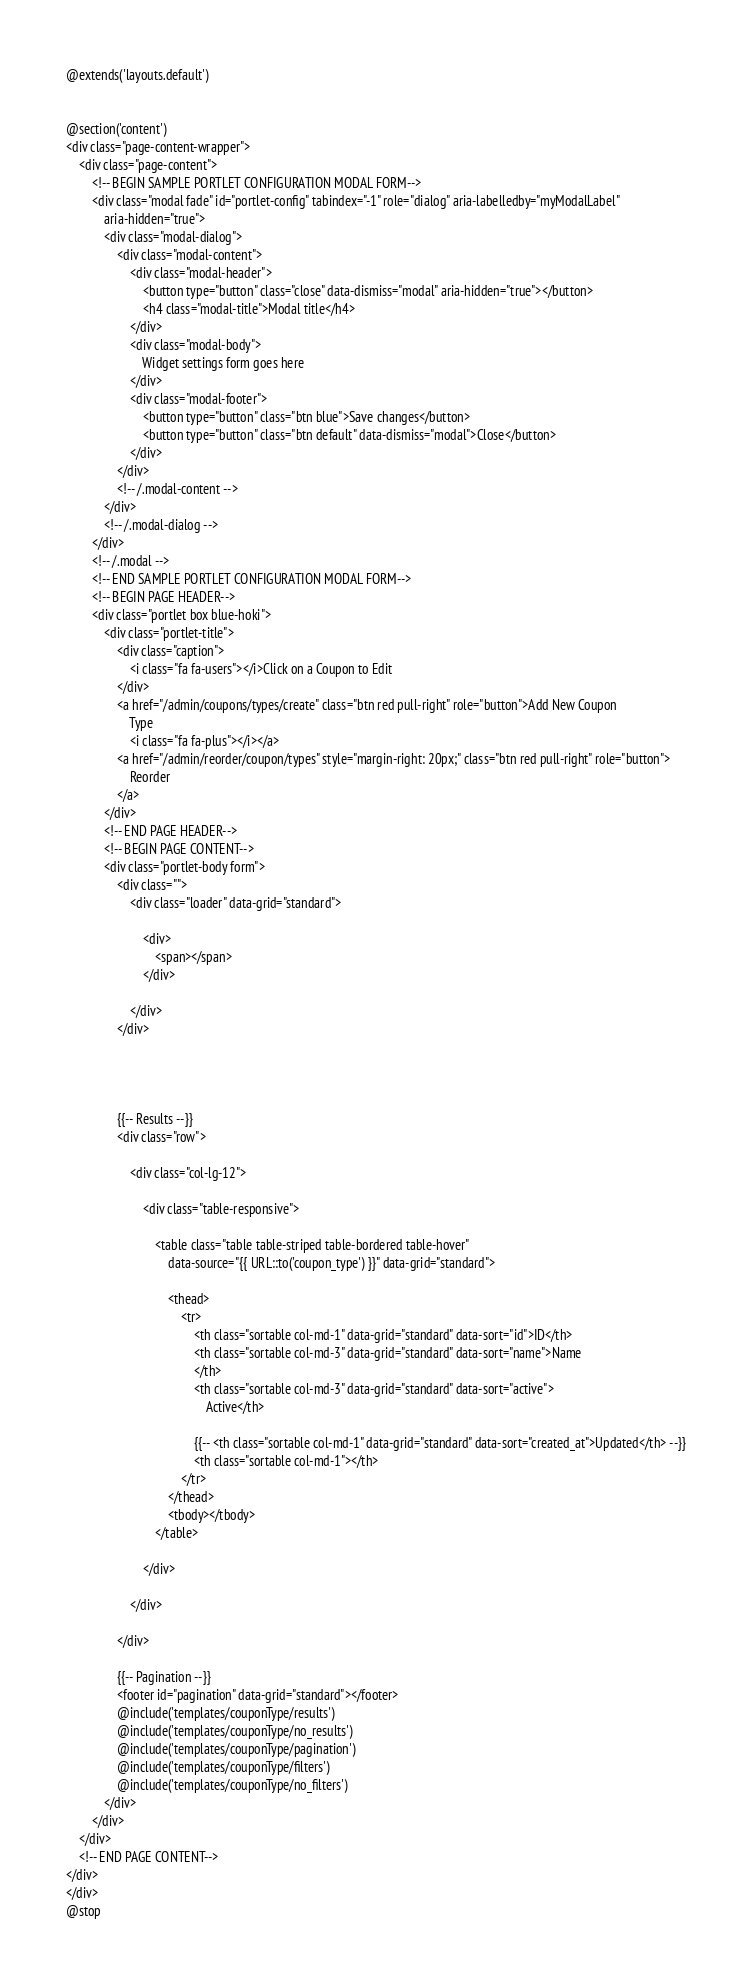<code> <loc_0><loc_0><loc_500><loc_500><_PHP_>@extends('layouts.default')


@section('content')
<div class="page-content-wrapper">
    <div class="page-content">
        <!-- BEGIN SAMPLE PORTLET CONFIGURATION MODAL FORM-->
        <div class="modal fade" id="portlet-config" tabindex="-1" role="dialog" aria-labelledby="myModalLabel"
            aria-hidden="true">
            <div class="modal-dialog">
                <div class="modal-content">
                    <div class="modal-header">
                        <button type="button" class="close" data-dismiss="modal" aria-hidden="true"></button>
                        <h4 class="modal-title">Modal title</h4>
                    </div>
                    <div class="modal-body">
                        Widget settings form goes here
                    </div>
                    <div class="modal-footer">
                        <button type="button" class="btn blue">Save changes</button>
                        <button type="button" class="btn default" data-dismiss="modal">Close</button>
                    </div>
                </div>
                <!-- /.modal-content -->
            </div>
            <!-- /.modal-dialog -->
        </div>
        <!-- /.modal -->
        <!-- END SAMPLE PORTLET CONFIGURATION MODAL FORM-->
        <!-- BEGIN PAGE HEADER-->
        <div class="portlet box blue-hoki">
            <div class="portlet-title">
                <div class="caption">
                    <i class="fa fa-users"></i>Click on a Coupon to Edit
                </div>
                <a href="/admin/coupons/types/create" class="btn red pull-right" role="button">Add New Coupon
                    Type
                    <i class="fa fa-plus"></i></a>
                <a href="/admin/reorder/coupon/types" style="margin-right: 20px;" class="btn red pull-right" role="button">
                    Reorder
                </a>
            </div>
            <!-- END PAGE HEADER-->
            <!-- BEGIN PAGE CONTENT-->
            <div class="portlet-body form">
                <div class="">
                    <div class="loader" data-grid="standard">

                        <div>
                            <span></span>
                        </div>

                    </div>
                </div>




                {{-- Results --}}
                <div class="row">

                    <div class="col-lg-12">

                        <div class="table-responsive">

                            <table class="table table-striped table-bordered table-hover"
                                data-source="{{ URL::to('coupon_type') }}" data-grid="standard">

                                <thead>
                                    <tr>
                                        <th class="sortable col-md-1" data-grid="standard" data-sort="id">ID</th>
                                        <th class="sortable col-md-3" data-grid="standard" data-sort="name">Name
                                        </th>
                                        <th class="sortable col-md-3" data-grid="standard" data-sort="active">
                                            Active</th>

                                        {{-- <th class="sortable col-md-1" data-grid="standard" data-sort="created_at">Updated</th> --}}
                                        <th class="sortable col-md-1"></th>
                                    </tr>
                                </thead>
                                <tbody></tbody>
                            </table>

                        </div>

                    </div>

                </div>

                {{-- Pagination --}}
                <footer id="pagination" data-grid="standard"></footer>
                @include('templates/couponType/results')
                @include('templates/couponType/no_results')
                @include('templates/couponType/pagination')
                @include('templates/couponType/filters')
                @include('templates/couponType/no_filters')
            </div>
        </div>
    </div>
    <!-- END PAGE CONTENT-->
</div>
</div>
@stop</code> 